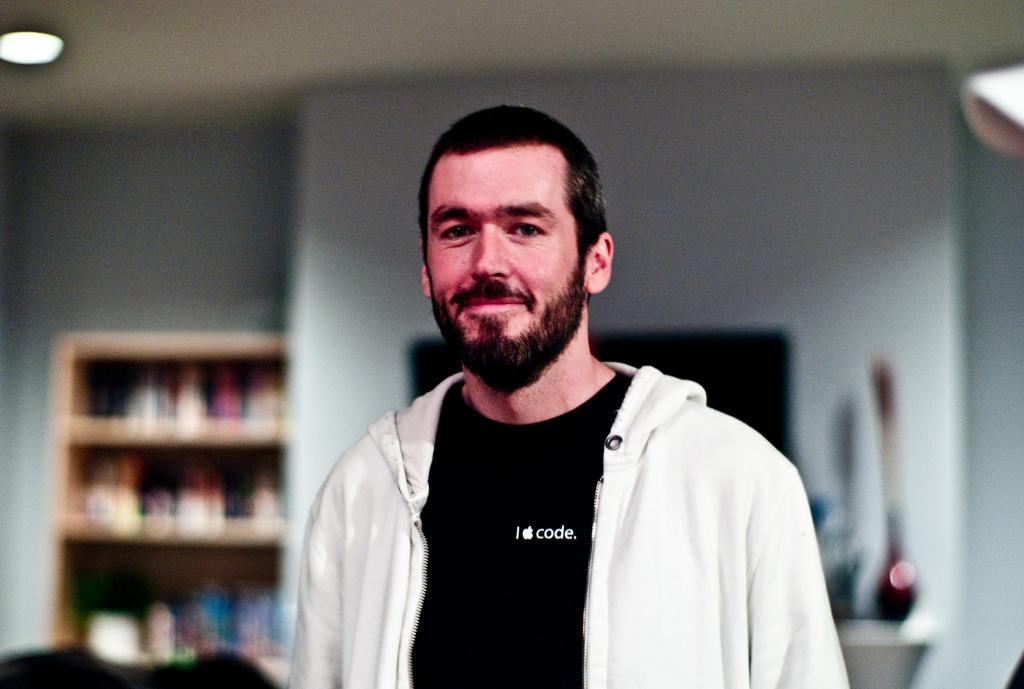<image>
Share a concise interpretation of the image provided. The man in the picture has a I apple code shirt on. 